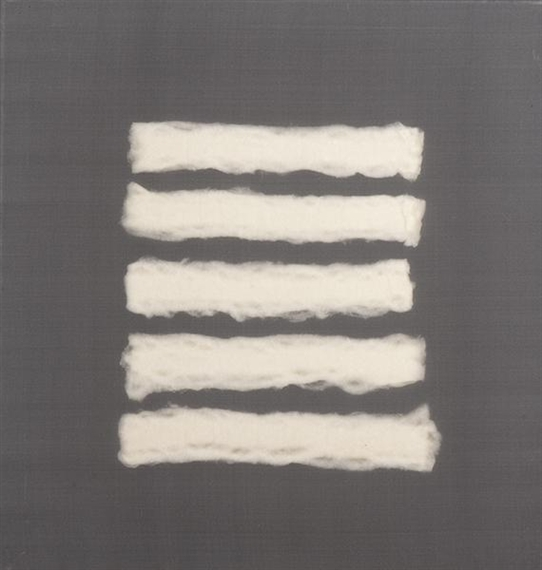Imagine this artwork being part of a different setting, like an alien planet. What would it represent there? On an alien planet, this artwork might be seen as a relic of an ancient civilization, a piece of cultural heritage that embodies the values and aesthetics of its creators. The white strips could be interpreted as symbols of cosmic balance and harmony, reflecting the alien society's reverence for simplicity and order. The contrast between the stark, gray background and the soft, organic lines might hint at the planet's varied landscapes, from barren rocks to lush vegetation. Alternatively, this piece could be viewed as a form of communication, a language of shapes and textures used by the alien species to convey abstract concepts and emotions. In such a context, the artwork would not only be a testament to the aliens' artistic sensibilities but also a window into their ways of understanding and interacting with their universe. What if the white lines were made of a precious material on that alien planet? How would that change the interpretation? If the white lines were made of a precious material on the alien planet, such as a rare mineral or a mystical substance with special properties, the artwork would take on a new layer of significance. It might be revered as a sacred object, imbued with spiritual or ceremonial importance. The precious material could symbolize purity, strength, or even divine favor, elevating the artwork from a mere decorative piece to a revered artifact. This change in material would suggest that the artist was not only creating a visual representation but also imbuing the work with deeper, perhaps even mystical meanings. Such an interpretation would highlight the alien society's values and beliefs, offering insight into their relationship with nature and the cosmos. The piece could become a focal point for rituals, storytelling, or historical preservation, emphasizing its role in the cultural and spiritual life of the planet. 